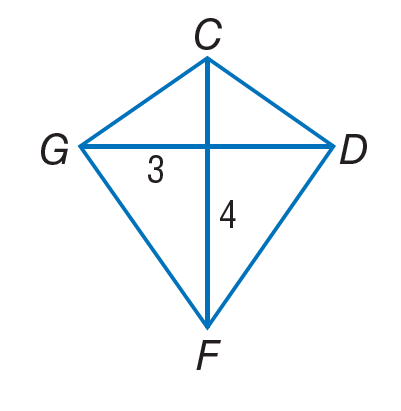Question: If C D F G is a kite, find G F.
Choices:
A. 3
B. 4
C. 5
D. 7
Answer with the letter. Answer: C 